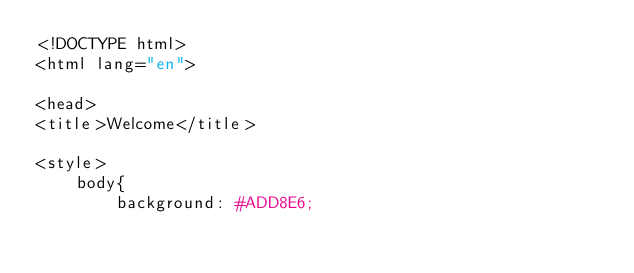Convert code to text. <code><loc_0><loc_0><loc_500><loc_500><_PHP_><!DOCTYPE html>
<html lang="en">

<head>
<title>Welcome</title>

<style>
    body{
        background: #ADD8E6;</code> 